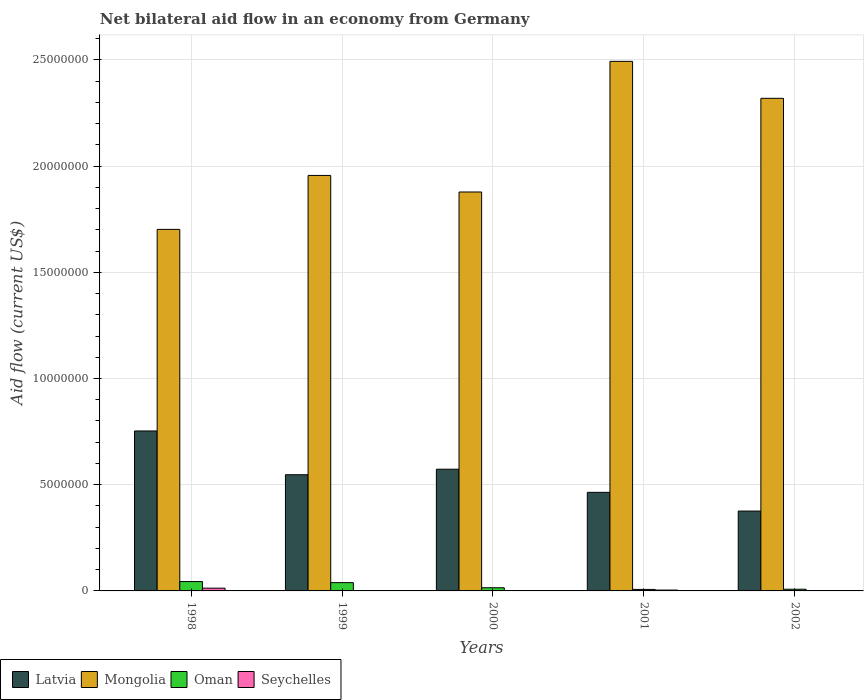How many different coloured bars are there?
Your response must be concise. 4. Are the number of bars on each tick of the X-axis equal?
Your response must be concise. No. How many bars are there on the 2nd tick from the left?
Your response must be concise. 3. How many bars are there on the 3rd tick from the right?
Your answer should be very brief. 3. What is the net bilateral aid flow in Mongolia in 2001?
Offer a terse response. 2.49e+07. Across all years, what is the maximum net bilateral aid flow in Mongolia?
Make the answer very short. 2.49e+07. Across all years, what is the minimum net bilateral aid flow in Latvia?
Make the answer very short. 3.76e+06. What is the total net bilateral aid flow in Latvia in the graph?
Offer a terse response. 2.71e+07. What is the difference between the net bilateral aid flow in Mongolia in 1999 and that in 2002?
Provide a succinct answer. -3.63e+06. What is the difference between the net bilateral aid flow in Oman in 1998 and the net bilateral aid flow in Seychelles in 2001?
Your answer should be very brief. 4.00e+05. What is the average net bilateral aid flow in Oman per year?
Give a very brief answer. 2.26e+05. In the year 2000, what is the difference between the net bilateral aid flow in Latvia and net bilateral aid flow in Oman?
Keep it short and to the point. 5.58e+06. In how many years, is the net bilateral aid flow in Mongolia greater than 2000000 US$?
Your response must be concise. 5. What is the ratio of the net bilateral aid flow in Mongolia in 1998 to that in 2001?
Provide a short and direct response. 0.68. What is the difference between the highest and the second highest net bilateral aid flow in Oman?
Provide a short and direct response. 5.00e+04. What is the difference between the highest and the lowest net bilateral aid flow in Mongolia?
Your answer should be very brief. 7.91e+06. Is it the case that in every year, the sum of the net bilateral aid flow in Mongolia and net bilateral aid flow in Oman is greater than the sum of net bilateral aid flow in Seychelles and net bilateral aid flow in Latvia?
Provide a succinct answer. Yes. How many bars are there?
Keep it short and to the point. 17. How many years are there in the graph?
Make the answer very short. 5. What is the difference between two consecutive major ticks on the Y-axis?
Your answer should be compact. 5.00e+06. Does the graph contain any zero values?
Offer a very short reply. Yes. Where does the legend appear in the graph?
Your answer should be compact. Bottom left. What is the title of the graph?
Ensure brevity in your answer.  Net bilateral aid flow in an economy from Germany. Does "Norway" appear as one of the legend labels in the graph?
Your answer should be very brief. No. What is the Aid flow (current US$) of Latvia in 1998?
Provide a short and direct response. 7.53e+06. What is the Aid flow (current US$) of Mongolia in 1998?
Give a very brief answer. 1.70e+07. What is the Aid flow (current US$) in Oman in 1998?
Provide a succinct answer. 4.40e+05. What is the Aid flow (current US$) of Latvia in 1999?
Offer a terse response. 5.47e+06. What is the Aid flow (current US$) of Mongolia in 1999?
Provide a succinct answer. 1.96e+07. What is the Aid flow (current US$) of Seychelles in 1999?
Give a very brief answer. 0. What is the Aid flow (current US$) of Latvia in 2000?
Ensure brevity in your answer.  5.73e+06. What is the Aid flow (current US$) of Mongolia in 2000?
Keep it short and to the point. 1.88e+07. What is the Aid flow (current US$) of Oman in 2000?
Offer a very short reply. 1.50e+05. What is the Aid flow (current US$) in Seychelles in 2000?
Keep it short and to the point. 0. What is the Aid flow (current US$) of Latvia in 2001?
Make the answer very short. 4.64e+06. What is the Aid flow (current US$) in Mongolia in 2001?
Your answer should be very brief. 2.49e+07. What is the Aid flow (current US$) of Latvia in 2002?
Make the answer very short. 3.76e+06. What is the Aid flow (current US$) of Mongolia in 2002?
Your response must be concise. 2.32e+07. Across all years, what is the maximum Aid flow (current US$) of Latvia?
Keep it short and to the point. 7.53e+06. Across all years, what is the maximum Aid flow (current US$) in Mongolia?
Provide a succinct answer. 2.49e+07. Across all years, what is the minimum Aid flow (current US$) in Latvia?
Ensure brevity in your answer.  3.76e+06. Across all years, what is the minimum Aid flow (current US$) in Mongolia?
Provide a short and direct response. 1.70e+07. Across all years, what is the minimum Aid flow (current US$) in Seychelles?
Your answer should be compact. 0. What is the total Aid flow (current US$) in Latvia in the graph?
Your answer should be compact. 2.71e+07. What is the total Aid flow (current US$) in Mongolia in the graph?
Offer a very short reply. 1.03e+08. What is the total Aid flow (current US$) of Oman in the graph?
Provide a succinct answer. 1.13e+06. What is the difference between the Aid flow (current US$) in Latvia in 1998 and that in 1999?
Make the answer very short. 2.06e+06. What is the difference between the Aid flow (current US$) of Mongolia in 1998 and that in 1999?
Provide a succinct answer. -2.54e+06. What is the difference between the Aid flow (current US$) in Latvia in 1998 and that in 2000?
Provide a succinct answer. 1.80e+06. What is the difference between the Aid flow (current US$) of Mongolia in 1998 and that in 2000?
Keep it short and to the point. -1.76e+06. What is the difference between the Aid flow (current US$) of Latvia in 1998 and that in 2001?
Make the answer very short. 2.89e+06. What is the difference between the Aid flow (current US$) in Mongolia in 1998 and that in 2001?
Offer a very short reply. -7.91e+06. What is the difference between the Aid flow (current US$) in Seychelles in 1998 and that in 2001?
Provide a succinct answer. 9.00e+04. What is the difference between the Aid flow (current US$) of Latvia in 1998 and that in 2002?
Keep it short and to the point. 3.77e+06. What is the difference between the Aid flow (current US$) in Mongolia in 1998 and that in 2002?
Ensure brevity in your answer.  -6.17e+06. What is the difference between the Aid flow (current US$) of Oman in 1998 and that in 2002?
Offer a terse response. 3.60e+05. What is the difference between the Aid flow (current US$) of Mongolia in 1999 and that in 2000?
Offer a terse response. 7.80e+05. What is the difference between the Aid flow (current US$) of Oman in 1999 and that in 2000?
Your answer should be compact. 2.40e+05. What is the difference between the Aid flow (current US$) of Latvia in 1999 and that in 2001?
Make the answer very short. 8.30e+05. What is the difference between the Aid flow (current US$) of Mongolia in 1999 and that in 2001?
Your answer should be compact. -5.37e+06. What is the difference between the Aid flow (current US$) in Latvia in 1999 and that in 2002?
Give a very brief answer. 1.71e+06. What is the difference between the Aid flow (current US$) in Mongolia in 1999 and that in 2002?
Make the answer very short. -3.63e+06. What is the difference between the Aid flow (current US$) in Oman in 1999 and that in 2002?
Your answer should be compact. 3.10e+05. What is the difference between the Aid flow (current US$) of Latvia in 2000 and that in 2001?
Your response must be concise. 1.09e+06. What is the difference between the Aid flow (current US$) in Mongolia in 2000 and that in 2001?
Give a very brief answer. -6.15e+06. What is the difference between the Aid flow (current US$) of Latvia in 2000 and that in 2002?
Your answer should be compact. 1.97e+06. What is the difference between the Aid flow (current US$) in Mongolia in 2000 and that in 2002?
Keep it short and to the point. -4.41e+06. What is the difference between the Aid flow (current US$) in Oman in 2000 and that in 2002?
Provide a short and direct response. 7.00e+04. What is the difference between the Aid flow (current US$) of Latvia in 2001 and that in 2002?
Make the answer very short. 8.80e+05. What is the difference between the Aid flow (current US$) of Mongolia in 2001 and that in 2002?
Your answer should be very brief. 1.74e+06. What is the difference between the Aid flow (current US$) in Oman in 2001 and that in 2002?
Offer a very short reply. -10000. What is the difference between the Aid flow (current US$) of Latvia in 1998 and the Aid flow (current US$) of Mongolia in 1999?
Make the answer very short. -1.20e+07. What is the difference between the Aid flow (current US$) of Latvia in 1998 and the Aid flow (current US$) of Oman in 1999?
Make the answer very short. 7.14e+06. What is the difference between the Aid flow (current US$) in Mongolia in 1998 and the Aid flow (current US$) in Oman in 1999?
Provide a short and direct response. 1.66e+07. What is the difference between the Aid flow (current US$) in Latvia in 1998 and the Aid flow (current US$) in Mongolia in 2000?
Offer a very short reply. -1.12e+07. What is the difference between the Aid flow (current US$) in Latvia in 1998 and the Aid flow (current US$) in Oman in 2000?
Offer a very short reply. 7.38e+06. What is the difference between the Aid flow (current US$) in Mongolia in 1998 and the Aid flow (current US$) in Oman in 2000?
Keep it short and to the point. 1.69e+07. What is the difference between the Aid flow (current US$) in Latvia in 1998 and the Aid flow (current US$) in Mongolia in 2001?
Keep it short and to the point. -1.74e+07. What is the difference between the Aid flow (current US$) in Latvia in 1998 and the Aid flow (current US$) in Oman in 2001?
Make the answer very short. 7.46e+06. What is the difference between the Aid flow (current US$) in Latvia in 1998 and the Aid flow (current US$) in Seychelles in 2001?
Make the answer very short. 7.49e+06. What is the difference between the Aid flow (current US$) of Mongolia in 1998 and the Aid flow (current US$) of Oman in 2001?
Keep it short and to the point. 1.70e+07. What is the difference between the Aid flow (current US$) of Mongolia in 1998 and the Aid flow (current US$) of Seychelles in 2001?
Offer a terse response. 1.70e+07. What is the difference between the Aid flow (current US$) of Oman in 1998 and the Aid flow (current US$) of Seychelles in 2001?
Offer a terse response. 4.00e+05. What is the difference between the Aid flow (current US$) in Latvia in 1998 and the Aid flow (current US$) in Mongolia in 2002?
Give a very brief answer. -1.57e+07. What is the difference between the Aid flow (current US$) of Latvia in 1998 and the Aid flow (current US$) of Oman in 2002?
Provide a short and direct response. 7.45e+06. What is the difference between the Aid flow (current US$) in Mongolia in 1998 and the Aid flow (current US$) in Oman in 2002?
Offer a very short reply. 1.69e+07. What is the difference between the Aid flow (current US$) in Latvia in 1999 and the Aid flow (current US$) in Mongolia in 2000?
Keep it short and to the point. -1.33e+07. What is the difference between the Aid flow (current US$) in Latvia in 1999 and the Aid flow (current US$) in Oman in 2000?
Make the answer very short. 5.32e+06. What is the difference between the Aid flow (current US$) of Mongolia in 1999 and the Aid flow (current US$) of Oman in 2000?
Offer a terse response. 1.94e+07. What is the difference between the Aid flow (current US$) of Latvia in 1999 and the Aid flow (current US$) of Mongolia in 2001?
Provide a short and direct response. -1.95e+07. What is the difference between the Aid flow (current US$) in Latvia in 1999 and the Aid flow (current US$) in Oman in 2001?
Your response must be concise. 5.40e+06. What is the difference between the Aid flow (current US$) of Latvia in 1999 and the Aid flow (current US$) of Seychelles in 2001?
Make the answer very short. 5.43e+06. What is the difference between the Aid flow (current US$) in Mongolia in 1999 and the Aid flow (current US$) in Oman in 2001?
Ensure brevity in your answer.  1.95e+07. What is the difference between the Aid flow (current US$) in Mongolia in 1999 and the Aid flow (current US$) in Seychelles in 2001?
Provide a short and direct response. 1.95e+07. What is the difference between the Aid flow (current US$) of Latvia in 1999 and the Aid flow (current US$) of Mongolia in 2002?
Your response must be concise. -1.77e+07. What is the difference between the Aid flow (current US$) in Latvia in 1999 and the Aid flow (current US$) in Oman in 2002?
Provide a short and direct response. 5.39e+06. What is the difference between the Aid flow (current US$) in Mongolia in 1999 and the Aid flow (current US$) in Oman in 2002?
Offer a very short reply. 1.95e+07. What is the difference between the Aid flow (current US$) of Latvia in 2000 and the Aid flow (current US$) of Mongolia in 2001?
Your answer should be very brief. -1.92e+07. What is the difference between the Aid flow (current US$) in Latvia in 2000 and the Aid flow (current US$) in Oman in 2001?
Make the answer very short. 5.66e+06. What is the difference between the Aid flow (current US$) of Latvia in 2000 and the Aid flow (current US$) of Seychelles in 2001?
Your answer should be compact. 5.69e+06. What is the difference between the Aid flow (current US$) in Mongolia in 2000 and the Aid flow (current US$) in Oman in 2001?
Give a very brief answer. 1.87e+07. What is the difference between the Aid flow (current US$) in Mongolia in 2000 and the Aid flow (current US$) in Seychelles in 2001?
Make the answer very short. 1.87e+07. What is the difference between the Aid flow (current US$) in Oman in 2000 and the Aid flow (current US$) in Seychelles in 2001?
Offer a terse response. 1.10e+05. What is the difference between the Aid flow (current US$) in Latvia in 2000 and the Aid flow (current US$) in Mongolia in 2002?
Provide a short and direct response. -1.75e+07. What is the difference between the Aid flow (current US$) in Latvia in 2000 and the Aid flow (current US$) in Oman in 2002?
Make the answer very short. 5.65e+06. What is the difference between the Aid flow (current US$) of Mongolia in 2000 and the Aid flow (current US$) of Oman in 2002?
Provide a succinct answer. 1.87e+07. What is the difference between the Aid flow (current US$) of Latvia in 2001 and the Aid flow (current US$) of Mongolia in 2002?
Provide a short and direct response. -1.86e+07. What is the difference between the Aid flow (current US$) of Latvia in 2001 and the Aid flow (current US$) of Oman in 2002?
Give a very brief answer. 4.56e+06. What is the difference between the Aid flow (current US$) of Mongolia in 2001 and the Aid flow (current US$) of Oman in 2002?
Provide a short and direct response. 2.48e+07. What is the average Aid flow (current US$) in Latvia per year?
Give a very brief answer. 5.43e+06. What is the average Aid flow (current US$) of Mongolia per year?
Keep it short and to the point. 2.07e+07. What is the average Aid flow (current US$) in Oman per year?
Give a very brief answer. 2.26e+05. What is the average Aid flow (current US$) in Seychelles per year?
Your response must be concise. 3.40e+04. In the year 1998, what is the difference between the Aid flow (current US$) of Latvia and Aid flow (current US$) of Mongolia?
Ensure brevity in your answer.  -9.49e+06. In the year 1998, what is the difference between the Aid flow (current US$) in Latvia and Aid flow (current US$) in Oman?
Offer a very short reply. 7.09e+06. In the year 1998, what is the difference between the Aid flow (current US$) in Latvia and Aid flow (current US$) in Seychelles?
Ensure brevity in your answer.  7.40e+06. In the year 1998, what is the difference between the Aid flow (current US$) in Mongolia and Aid flow (current US$) in Oman?
Provide a succinct answer. 1.66e+07. In the year 1998, what is the difference between the Aid flow (current US$) of Mongolia and Aid flow (current US$) of Seychelles?
Provide a short and direct response. 1.69e+07. In the year 1999, what is the difference between the Aid flow (current US$) in Latvia and Aid flow (current US$) in Mongolia?
Provide a succinct answer. -1.41e+07. In the year 1999, what is the difference between the Aid flow (current US$) in Latvia and Aid flow (current US$) in Oman?
Ensure brevity in your answer.  5.08e+06. In the year 1999, what is the difference between the Aid flow (current US$) of Mongolia and Aid flow (current US$) of Oman?
Give a very brief answer. 1.92e+07. In the year 2000, what is the difference between the Aid flow (current US$) in Latvia and Aid flow (current US$) in Mongolia?
Keep it short and to the point. -1.30e+07. In the year 2000, what is the difference between the Aid flow (current US$) of Latvia and Aid flow (current US$) of Oman?
Give a very brief answer. 5.58e+06. In the year 2000, what is the difference between the Aid flow (current US$) of Mongolia and Aid flow (current US$) of Oman?
Provide a succinct answer. 1.86e+07. In the year 2001, what is the difference between the Aid flow (current US$) of Latvia and Aid flow (current US$) of Mongolia?
Make the answer very short. -2.03e+07. In the year 2001, what is the difference between the Aid flow (current US$) in Latvia and Aid flow (current US$) in Oman?
Ensure brevity in your answer.  4.57e+06. In the year 2001, what is the difference between the Aid flow (current US$) of Latvia and Aid flow (current US$) of Seychelles?
Offer a terse response. 4.60e+06. In the year 2001, what is the difference between the Aid flow (current US$) of Mongolia and Aid flow (current US$) of Oman?
Your answer should be compact. 2.49e+07. In the year 2001, what is the difference between the Aid flow (current US$) in Mongolia and Aid flow (current US$) in Seychelles?
Provide a succinct answer. 2.49e+07. In the year 2002, what is the difference between the Aid flow (current US$) in Latvia and Aid flow (current US$) in Mongolia?
Your answer should be compact. -1.94e+07. In the year 2002, what is the difference between the Aid flow (current US$) of Latvia and Aid flow (current US$) of Oman?
Provide a short and direct response. 3.68e+06. In the year 2002, what is the difference between the Aid flow (current US$) of Mongolia and Aid flow (current US$) of Oman?
Make the answer very short. 2.31e+07. What is the ratio of the Aid flow (current US$) in Latvia in 1998 to that in 1999?
Offer a very short reply. 1.38. What is the ratio of the Aid flow (current US$) of Mongolia in 1998 to that in 1999?
Offer a very short reply. 0.87. What is the ratio of the Aid flow (current US$) in Oman in 1998 to that in 1999?
Offer a very short reply. 1.13. What is the ratio of the Aid flow (current US$) of Latvia in 1998 to that in 2000?
Offer a terse response. 1.31. What is the ratio of the Aid flow (current US$) in Mongolia in 1998 to that in 2000?
Keep it short and to the point. 0.91. What is the ratio of the Aid flow (current US$) of Oman in 1998 to that in 2000?
Keep it short and to the point. 2.93. What is the ratio of the Aid flow (current US$) of Latvia in 1998 to that in 2001?
Give a very brief answer. 1.62. What is the ratio of the Aid flow (current US$) of Mongolia in 1998 to that in 2001?
Ensure brevity in your answer.  0.68. What is the ratio of the Aid flow (current US$) of Oman in 1998 to that in 2001?
Offer a terse response. 6.29. What is the ratio of the Aid flow (current US$) in Latvia in 1998 to that in 2002?
Offer a terse response. 2. What is the ratio of the Aid flow (current US$) in Mongolia in 1998 to that in 2002?
Ensure brevity in your answer.  0.73. What is the ratio of the Aid flow (current US$) in Oman in 1998 to that in 2002?
Provide a short and direct response. 5.5. What is the ratio of the Aid flow (current US$) in Latvia in 1999 to that in 2000?
Offer a very short reply. 0.95. What is the ratio of the Aid flow (current US$) in Mongolia in 1999 to that in 2000?
Your answer should be very brief. 1.04. What is the ratio of the Aid flow (current US$) in Oman in 1999 to that in 2000?
Offer a terse response. 2.6. What is the ratio of the Aid flow (current US$) of Latvia in 1999 to that in 2001?
Ensure brevity in your answer.  1.18. What is the ratio of the Aid flow (current US$) of Mongolia in 1999 to that in 2001?
Make the answer very short. 0.78. What is the ratio of the Aid flow (current US$) in Oman in 1999 to that in 2001?
Give a very brief answer. 5.57. What is the ratio of the Aid flow (current US$) in Latvia in 1999 to that in 2002?
Your answer should be very brief. 1.45. What is the ratio of the Aid flow (current US$) of Mongolia in 1999 to that in 2002?
Your answer should be very brief. 0.84. What is the ratio of the Aid flow (current US$) in Oman in 1999 to that in 2002?
Provide a short and direct response. 4.88. What is the ratio of the Aid flow (current US$) in Latvia in 2000 to that in 2001?
Your response must be concise. 1.23. What is the ratio of the Aid flow (current US$) in Mongolia in 2000 to that in 2001?
Your answer should be compact. 0.75. What is the ratio of the Aid flow (current US$) in Oman in 2000 to that in 2001?
Provide a short and direct response. 2.14. What is the ratio of the Aid flow (current US$) in Latvia in 2000 to that in 2002?
Provide a succinct answer. 1.52. What is the ratio of the Aid flow (current US$) of Mongolia in 2000 to that in 2002?
Offer a terse response. 0.81. What is the ratio of the Aid flow (current US$) in Oman in 2000 to that in 2002?
Provide a short and direct response. 1.88. What is the ratio of the Aid flow (current US$) of Latvia in 2001 to that in 2002?
Your answer should be very brief. 1.23. What is the ratio of the Aid flow (current US$) in Mongolia in 2001 to that in 2002?
Offer a very short reply. 1.07. What is the ratio of the Aid flow (current US$) in Oman in 2001 to that in 2002?
Your response must be concise. 0.88. What is the difference between the highest and the second highest Aid flow (current US$) in Latvia?
Offer a very short reply. 1.80e+06. What is the difference between the highest and the second highest Aid flow (current US$) in Mongolia?
Make the answer very short. 1.74e+06. What is the difference between the highest and the lowest Aid flow (current US$) in Latvia?
Provide a short and direct response. 3.77e+06. What is the difference between the highest and the lowest Aid flow (current US$) in Mongolia?
Your answer should be compact. 7.91e+06. What is the difference between the highest and the lowest Aid flow (current US$) in Oman?
Ensure brevity in your answer.  3.70e+05. 